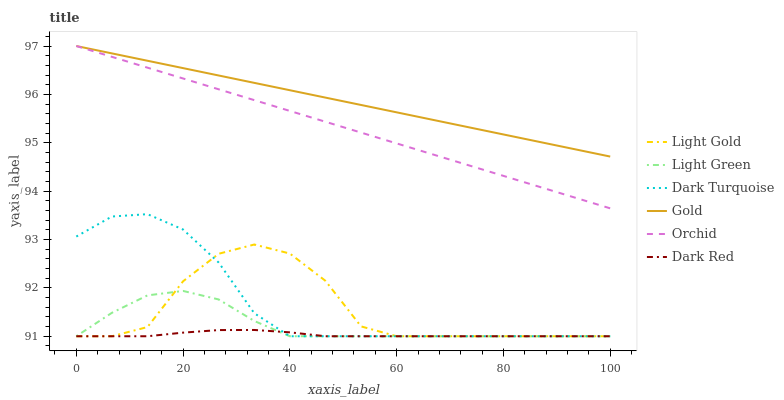Does Dark Red have the minimum area under the curve?
Answer yes or no. Yes. Does Gold have the maximum area under the curve?
Answer yes or no. Yes. Does Dark Turquoise have the minimum area under the curve?
Answer yes or no. No. Does Dark Turquoise have the maximum area under the curve?
Answer yes or no. No. Is Orchid the smoothest?
Answer yes or no. Yes. Is Light Gold the roughest?
Answer yes or no. Yes. Is Dark Turquoise the smoothest?
Answer yes or no. No. Is Dark Turquoise the roughest?
Answer yes or no. No. Does Dark Turquoise have the lowest value?
Answer yes or no. Yes. Does Orchid have the lowest value?
Answer yes or no. No. Does Orchid have the highest value?
Answer yes or no. Yes. Does Dark Turquoise have the highest value?
Answer yes or no. No. Is Light Gold less than Orchid?
Answer yes or no. Yes. Is Orchid greater than Light Gold?
Answer yes or no. Yes. Does Light Gold intersect Dark Turquoise?
Answer yes or no. Yes. Is Light Gold less than Dark Turquoise?
Answer yes or no. No. Is Light Gold greater than Dark Turquoise?
Answer yes or no. No. Does Light Gold intersect Orchid?
Answer yes or no. No. 